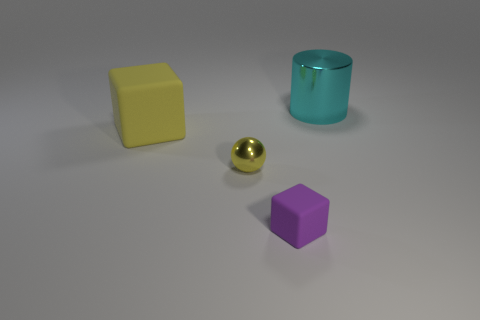Add 2 cyan shiny cylinders. How many objects exist? 6 Subtract all cylinders. How many objects are left? 3 Subtract 0 brown balls. How many objects are left? 4 Subtract all small metallic things. Subtract all big rubber objects. How many objects are left? 2 Add 3 cylinders. How many cylinders are left? 4 Add 1 small red matte blocks. How many small red matte blocks exist? 1 